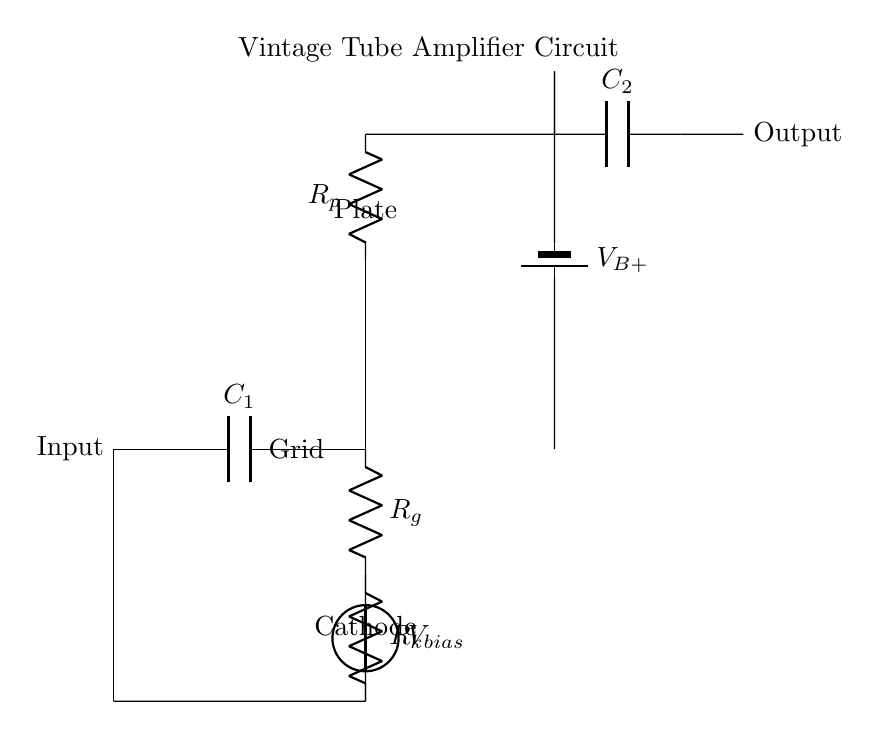What is the input component in this circuit? The input component is represented by a connection labeled "Input" and connects to a capacitor labeled C1.
Answer: Input What is the purpose of the capacitor C1? The capacitor C1 acts as a coupling capacitor, allowing AC signals to pass while blocking DC.
Answer: Coupling capacitor What type of component is used for the amplification in this circuit? The amplification is performed by a triode, specifically indicated in the diagram beside the label.
Answer: Triode What is the voltage connected to the biasing circuit? The voltage connected to the biasing circuit is labeled as V bias, represented in the voltage source symbol.
Answer: V bias How many resistors are in the circuit? The circuit includes two resistors, Rg and Rk, which are used for the grid and cathode circuits respectively.
Answer: Two What does the output node indicate? The output node is the point where the amplified signal is taken from, labeled as "Output."
Answer: Output What is the function of the battery V B+ in this circuit? The battery V B+ serves as the high voltage power supply for the amplifier circuit, providing the necessary voltage for operation.
Answer: Power supply 